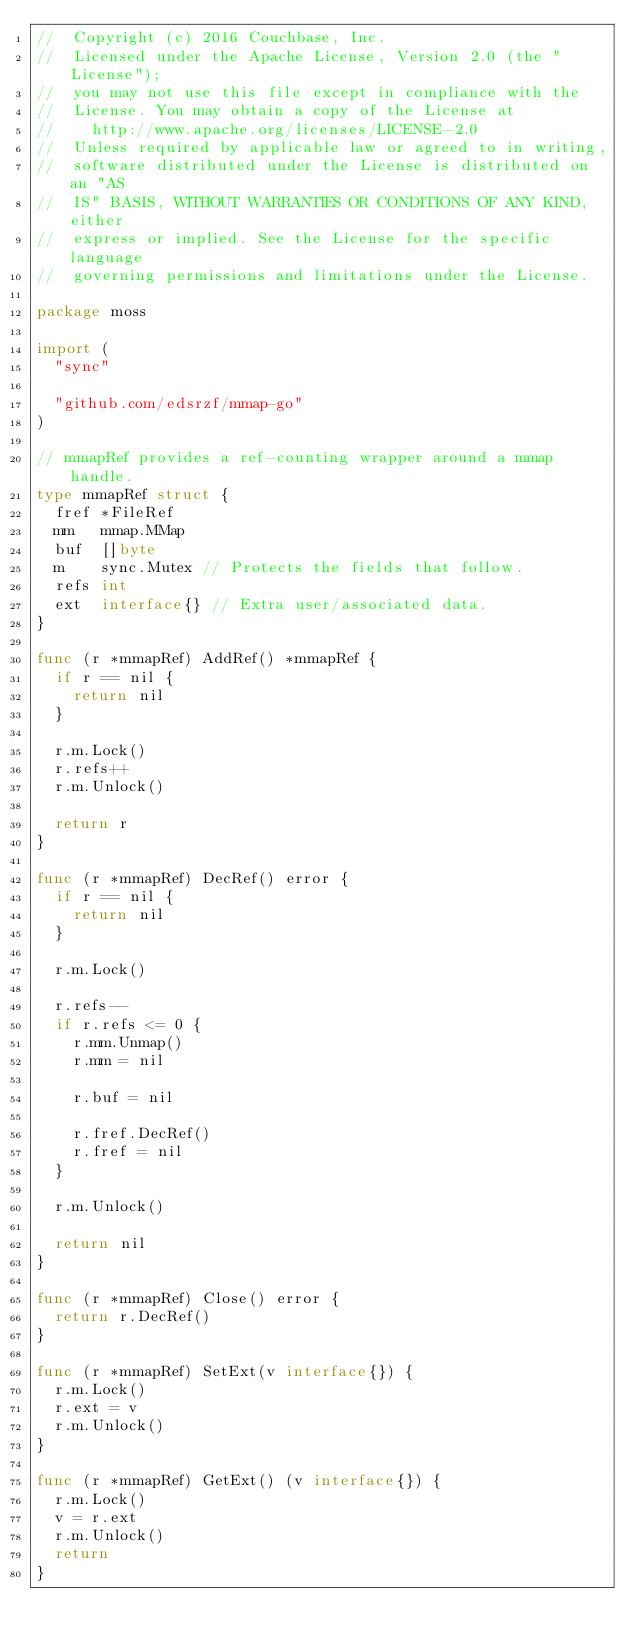Convert code to text. <code><loc_0><loc_0><loc_500><loc_500><_Go_>//  Copyright (c) 2016 Couchbase, Inc.
//  Licensed under the Apache License, Version 2.0 (the "License");
//  you may not use this file except in compliance with the
//  License. You may obtain a copy of the License at
//    http://www.apache.org/licenses/LICENSE-2.0
//  Unless required by applicable law or agreed to in writing,
//  software distributed under the License is distributed on an "AS
//  IS" BASIS, WITHOUT WARRANTIES OR CONDITIONS OF ANY KIND, either
//  express or implied. See the License for the specific language
//  governing permissions and limitations under the License.

package moss

import (
	"sync"

	"github.com/edsrzf/mmap-go"
)

// mmapRef provides a ref-counting wrapper around a mmap handle.
type mmapRef struct {
	fref *FileRef
	mm   mmap.MMap
	buf  []byte
	m    sync.Mutex // Protects the fields that follow.
	refs int
	ext  interface{} // Extra user/associated data.
}

func (r *mmapRef) AddRef() *mmapRef {
	if r == nil {
		return nil
	}

	r.m.Lock()
	r.refs++
	r.m.Unlock()

	return r
}

func (r *mmapRef) DecRef() error {
	if r == nil {
		return nil
	}

	r.m.Lock()

	r.refs--
	if r.refs <= 0 {
		r.mm.Unmap()
		r.mm = nil

		r.buf = nil

		r.fref.DecRef()
		r.fref = nil
	}

	r.m.Unlock()

	return nil
}

func (r *mmapRef) Close() error {
	return r.DecRef()
}

func (r *mmapRef) SetExt(v interface{}) {
	r.m.Lock()
	r.ext = v
	r.m.Unlock()
}

func (r *mmapRef) GetExt() (v interface{}) {
	r.m.Lock()
	v = r.ext
	r.m.Unlock()
	return
}
</code> 